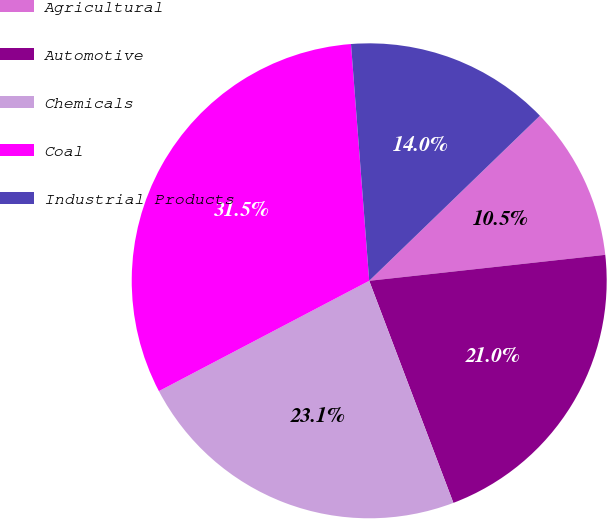Convert chart to OTSL. <chart><loc_0><loc_0><loc_500><loc_500><pie_chart><fcel>Agricultural<fcel>Automotive<fcel>Chemicals<fcel>Coal<fcel>Industrial Products<nl><fcel>10.49%<fcel>20.98%<fcel>23.08%<fcel>31.47%<fcel>13.99%<nl></chart> 